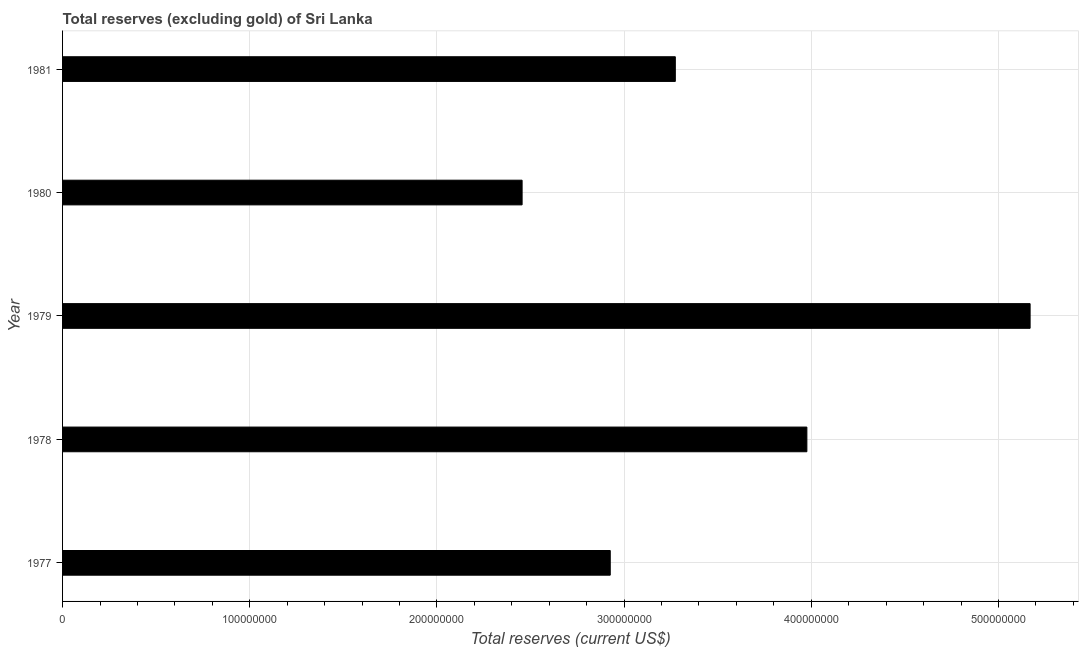Does the graph contain grids?
Provide a succinct answer. Yes. What is the title of the graph?
Give a very brief answer. Total reserves (excluding gold) of Sri Lanka. What is the label or title of the X-axis?
Ensure brevity in your answer.  Total reserves (current US$). What is the label or title of the Y-axis?
Offer a very short reply. Year. What is the total reserves (excluding gold) in 1977?
Offer a terse response. 2.93e+08. Across all years, what is the maximum total reserves (excluding gold)?
Give a very brief answer. 5.17e+08. Across all years, what is the minimum total reserves (excluding gold)?
Keep it short and to the point. 2.46e+08. In which year was the total reserves (excluding gold) maximum?
Offer a terse response. 1979. What is the sum of the total reserves (excluding gold)?
Ensure brevity in your answer.  1.78e+09. What is the difference between the total reserves (excluding gold) in 1978 and 1980?
Your answer should be very brief. 1.52e+08. What is the average total reserves (excluding gold) per year?
Provide a short and direct response. 3.56e+08. What is the median total reserves (excluding gold)?
Give a very brief answer. 3.27e+08. What is the ratio of the total reserves (excluding gold) in 1979 to that in 1981?
Your answer should be very brief. 1.58. Is the total reserves (excluding gold) in 1977 less than that in 1978?
Provide a short and direct response. Yes. Is the difference between the total reserves (excluding gold) in 1979 and 1981 greater than the difference between any two years?
Make the answer very short. No. What is the difference between the highest and the second highest total reserves (excluding gold)?
Give a very brief answer. 1.19e+08. What is the difference between the highest and the lowest total reserves (excluding gold)?
Offer a very short reply. 2.71e+08. In how many years, is the total reserves (excluding gold) greater than the average total reserves (excluding gold) taken over all years?
Your answer should be very brief. 2. How many years are there in the graph?
Offer a very short reply. 5. Are the values on the major ticks of X-axis written in scientific E-notation?
Keep it short and to the point. No. What is the Total reserves (current US$) of 1977?
Provide a short and direct response. 2.93e+08. What is the Total reserves (current US$) of 1978?
Provide a succinct answer. 3.98e+08. What is the Total reserves (current US$) in 1979?
Your answer should be very brief. 5.17e+08. What is the Total reserves (current US$) of 1980?
Ensure brevity in your answer.  2.46e+08. What is the Total reserves (current US$) in 1981?
Your response must be concise. 3.27e+08. What is the difference between the Total reserves (current US$) in 1977 and 1978?
Your answer should be very brief. -1.05e+08. What is the difference between the Total reserves (current US$) in 1977 and 1979?
Offer a terse response. -2.24e+08. What is the difference between the Total reserves (current US$) in 1977 and 1980?
Provide a short and direct response. 4.71e+07. What is the difference between the Total reserves (current US$) in 1977 and 1981?
Ensure brevity in your answer.  -3.48e+07. What is the difference between the Total reserves (current US$) in 1978 and 1979?
Make the answer very short. -1.19e+08. What is the difference between the Total reserves (current US$) in 1978 and 1980?
Provide a succinct answer. 1.52e+08. What is the difference between the Total reserves (current US$) in 1978 and 1981?
Provide a succinct answer. 7.03e+07. What is the difference between the Total reserves (current US$) in 1979 and 1980?
Your response must be concise. 2.71e+08. What is the difference between the Total reserves (current US$) in 1979 and 1981?
Keep it short and to the point. 1.90e+08. What is the difference between the Total reserves (current US$) in 1980 and 1981?
Provide a succinct answer. -8.19e+07. What is the ratio of the Total reserves (current US$) in 1977 to that in 1978?
Your answer should be very brief. 0.74. What is the ratio of the Total reserves (current US$) in 1977 to that in 1979?
Give a very brief answer. 0.57. What is the ratio of the Total reserves (current US$) in 1977 to that in 1980?
Offer a very short reply. 1.19. What is the ratio of the Total reserves (current US$) in 1977 to that in 1981?
Your answer should be compact. 0.89. What is the ratio of the Total reserves (current US$) in 1978 to that in 1979?
Offer a terse response. 0.77. What is the ratio of the Total reserves (current US$) in 1978 to that in 1980?
Provide a succinct answer. 1.62. What is the ratio of the Total reserves (current US$) in 1978 to that in 1981?
Keep it short and to the point. 1.22. What is the ratio of the Total reserves (current US$) in 1979 to that in 1980?
Offer a very short reply. 2.1. What is the ratio of the Total reserves (current US$) in 1979 to that in 1981?
Your response must be concise. 1.58. What is the ratio of the Total reserves (current US$) in 1980 to that in 1981?
Keep it short and to the point. 0.75. 